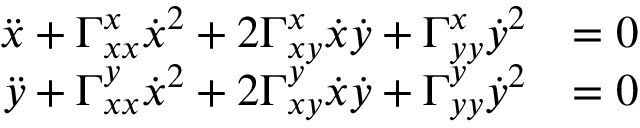<formula> <loc_0><loc_0><loc_500><loc_500>\begin{array} { r l } { \ddot { x } + \Gamma _ { x x } ^ { x } \dot { x } ^ { 2 } + 2 \Gamma _ { x y } ^ { x } \dot { x } \dot { y } + \Gamma _ { y y } ^ { x } \dot { y } ^ { 2 } } & { = 0 } \\ { \ddot { y } + \Gamma _ { x x } ^ { y } \dot { x } ^ { 2 } + 2 \Gamma _ { x y } ^ { y } \dot { x } \dot { y } + \Gamma _ { y y } ^ { y } \dot { y } ^ { 2 } } & { = 0 } \end{array}</formula> 